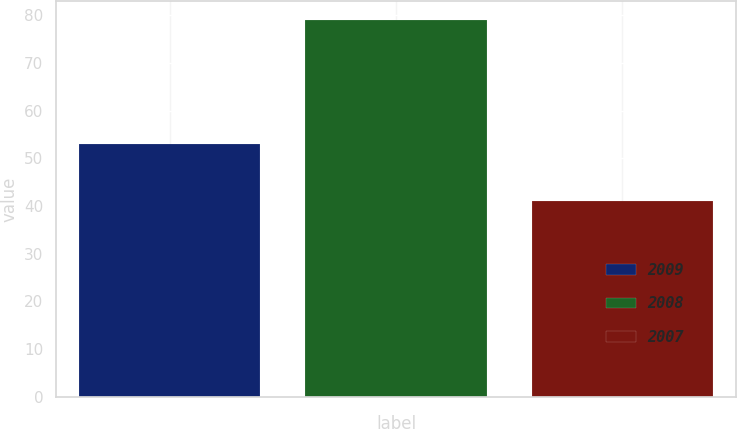Convert chart. <chart><loc_0><loc_0><loc_500><loc_500><bar_chart><fcel>2009<fcel>2008<fcel>2007<nl><fcel>53<fcel>79<fcel>41<nl></chart> 